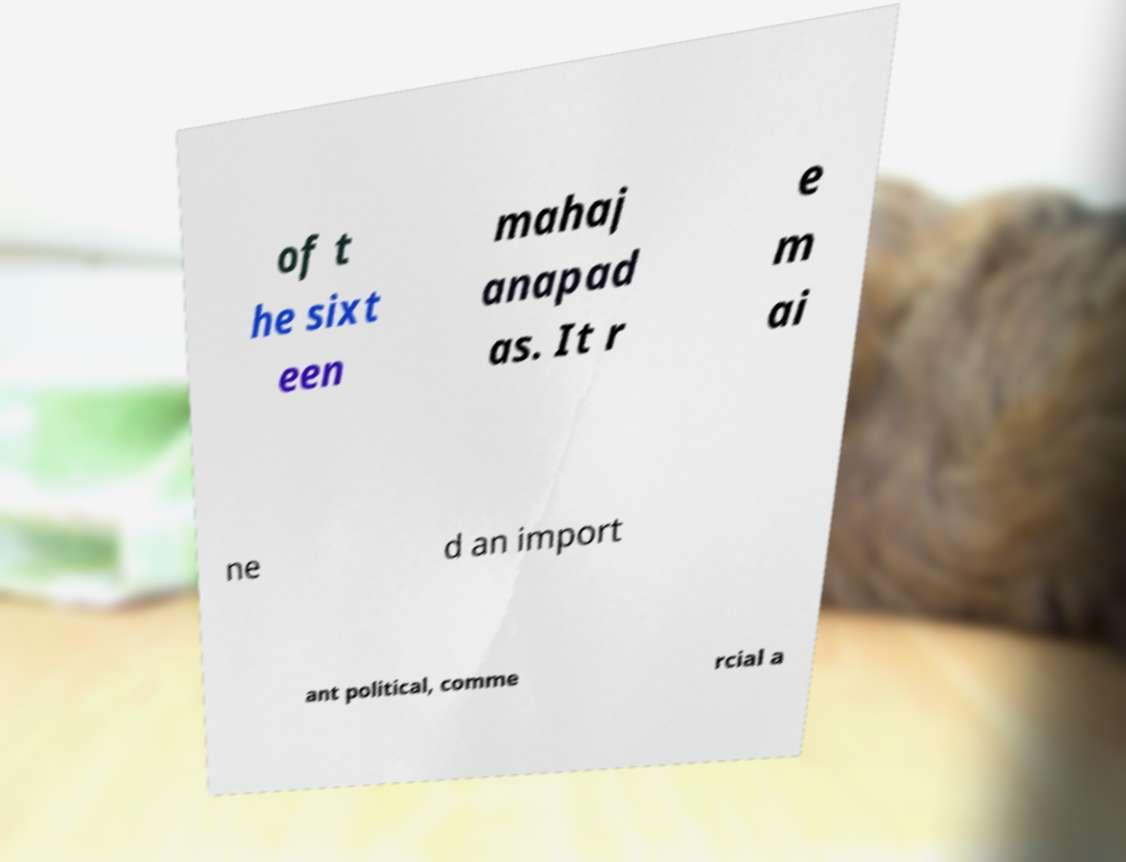For documentation purposes, I need the text within this image transcribed. Could you provide that? of t he sixt een mahaj anapad as. It r e m ai ne d an import ant political, comme rcial a 